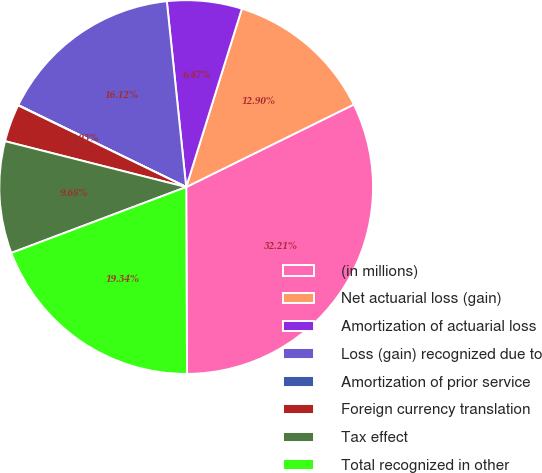Convert chart to OTSL. <chart><loc_0><loc_0><loc_500><loc_500><pie_chart><fcel>(in millions)<fcel>Net actuarial loss (gain)<fcel>Amortization of actuarial loss<fcel>Loss (gain) recognized due to<fcel>Amortization of prior service<fcel>Foreign currency translation<fcel>Tax effect<fcel>Total recognized in other<nl><fcel>32.21%<fcel>12.9%<fcel>6.47%<fcel>16.12%<fcel>0.03%<fcel>3.25%<fcel>9.68%<fcel>19.34%<nl></chart> 